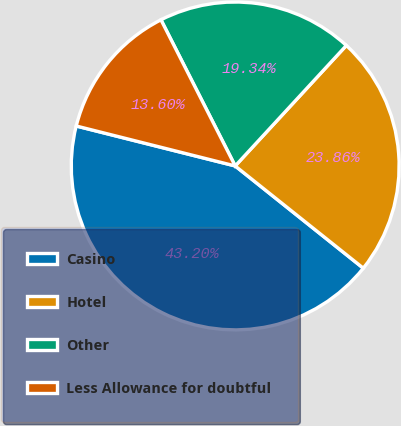<chart> <loc_0><loc_0><loc_500><loc_500><pie_chart><fcel>Casino<fcel>Hotel<fcel>Other<fcel>Less Allowance for doubtful<nl><fcel>43.2%<fcel>23.86%<fcel>19.34%<fcel>13.6%<nl></chart> 